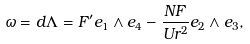<formula> <loc_0><loc_0><loc_500><loc_500>\omega = d \Lambda = F ^ { \prime } e _ { 1 } \wedge e _ { 4 } - \frac { N F } { U r ^ { 2 } } e _ { 2 } \wedge e _ { 3 } ,</formula> 